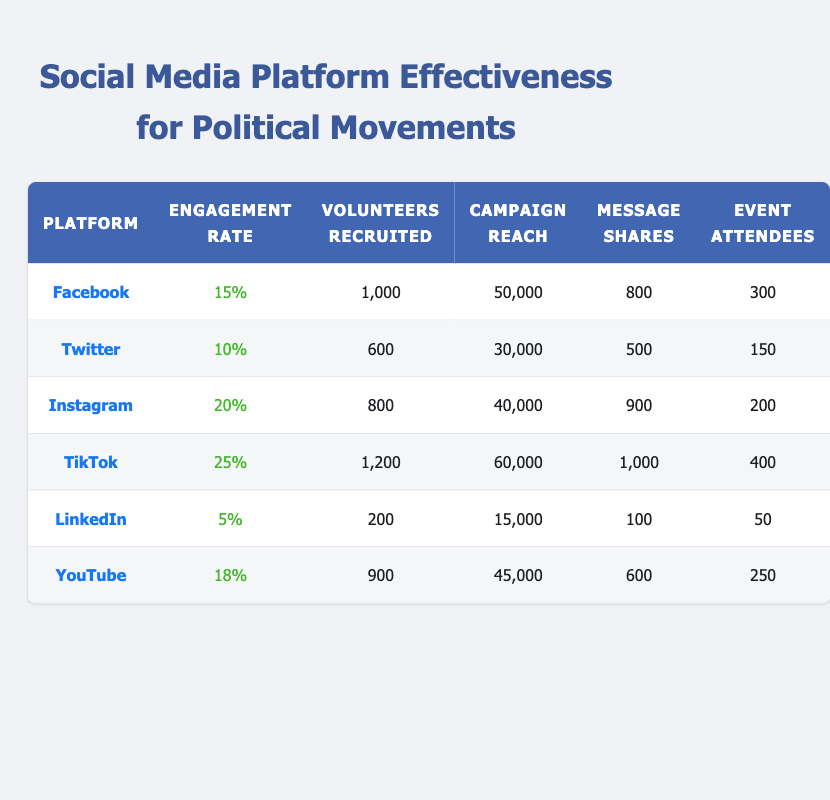What is the engagement rate of TikTok? The engagement rate for TikTok is presented in the table under the "Engagement Rate" column, which shows 25%.
Answer: 25% How many volunteers were recruited through Facebook? The table lists the number of volunteers recruited via Facebook in the "Volunteers Recruited" column, where it states 1,000 volunteers.
Answer: 1,000 Which platform had the highest campaign reach? To find the highest campaign reach, we can compare all values in the "Campaign Reach" column. TikTok has the highest reach at 60,000.
Answer: TikTok What is the total number of volunteers recruited across all platforms? We sum the volunteers recruited from each platform: 1,000 (Facebook) + 600 (Twitter) + 800 (Instagram) + 1,200 (TikTok) + 200 (LinkedIn) + 900 (YouTube) = 3,700 volunteers.
Answer: 3,700 Did LinkedIn recruit more volunteers than Twitter? The table indicates that LinkedIn recruited 200 volunteers, while Twitter recruited 600 volunteers. Therefore, LinkedIn did not recruit more than Twitter.
Answer: No Which platform had the least event attendees? By checking the "Event Attendees" column, we can observe that LinkedIn had the least number of attendees, with only 50.
Answer: LinkedIn If we look only at platforms with an engagement rate above 15%, which platforms are they? The platforms with engagement rates above 15% are TikTok (25%), Instagram (20%), and Facebook (15%). Thus, Facebook is included.
Answer: TikTok, Instagram, Facebook What is the average number of event attendees across all platforms? To find the average, we sum the attendees: 300 (Facebook) + 150 (Twitter) + 200 (Instagram) + 400 (TikTok) + 50 (LinkedIn) + 250 (YouTube) = 1,350 attendees. We divide by 6 platforms to get an average of 1,350/6 = 225.
Answer: 225 Which platform had the highest message shares? The "Message Shares" column shows that TikTok received the highest shares, totaling 1,000.
Answer: TikTok 